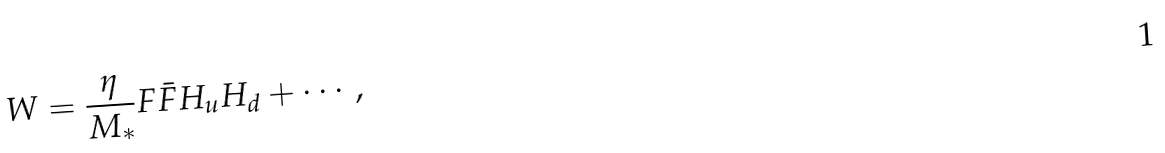Convert formula to latex. <formula><loc_0><loc_0><loc_500><loc_500>W = \frac { \eta } { M _ { * } } F \bar { F } H _ { u } H _ { d } + \cdots ,</formula> 